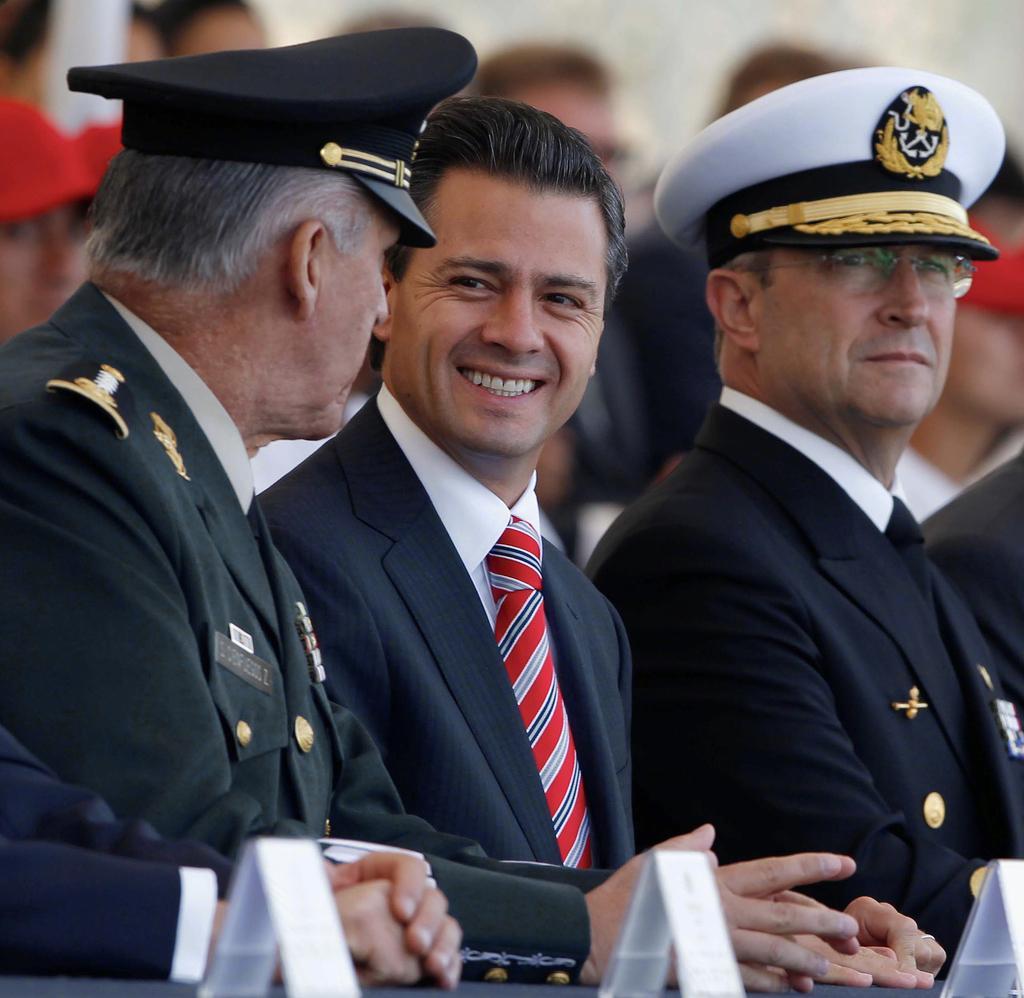Could you give a brief overview of what you see in this image? In this picture I can see there are three persons sitting on the chairs at the table and the person at the center is wearing a blazer and the persons sitting on to left and right are wearing uniforms with caps and in the backdrop there are few people standing and the backdrop is blurred. 